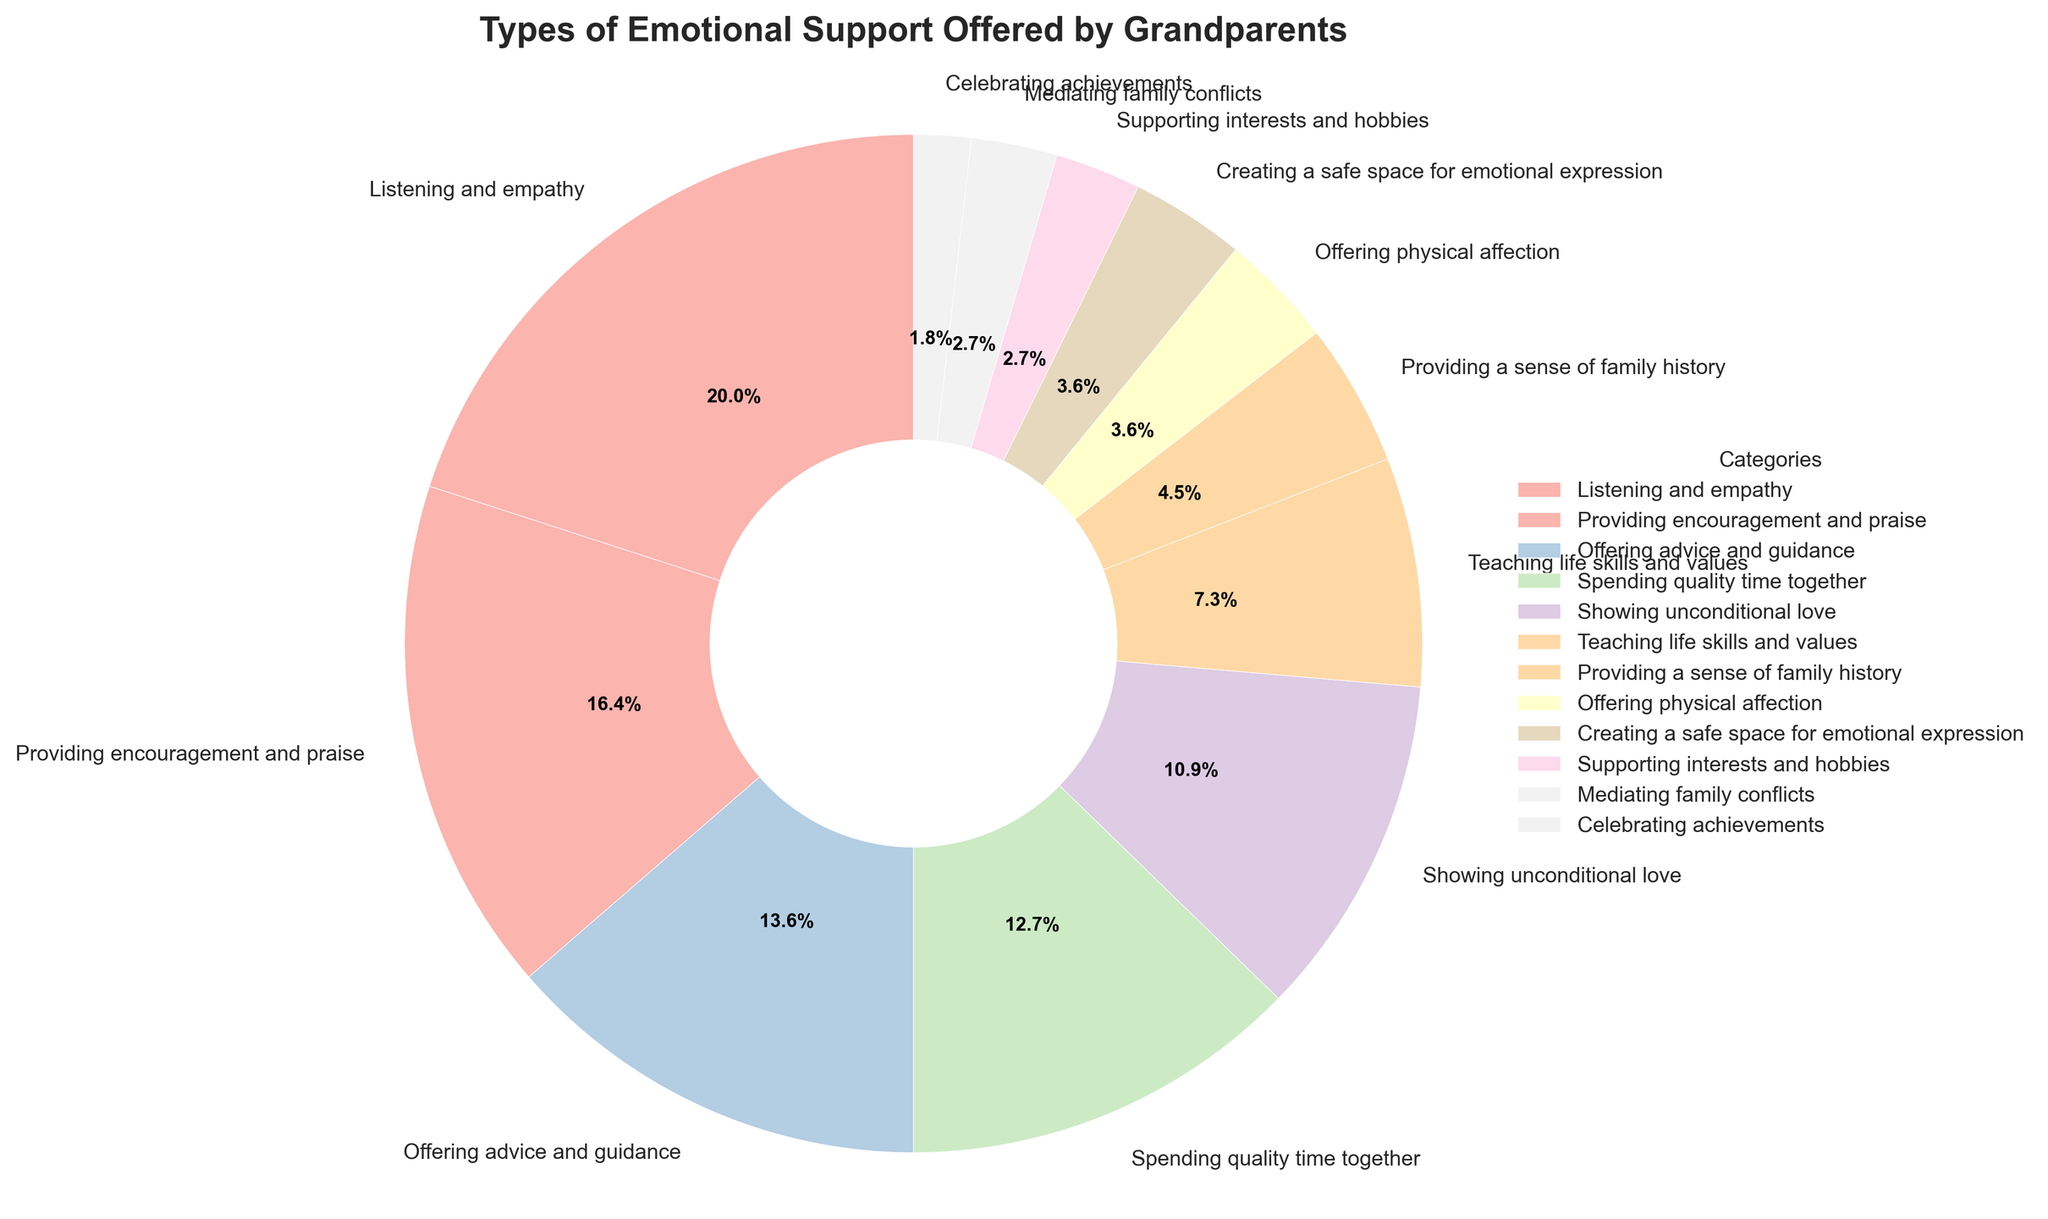What is the largest category of emotional support offered by grandparents? The largest slice of the pie chart represents the category with the highest percentage. Here, "Listening and empathy" has the largest slice, which is 22%.
Answer: Listening and empathy Which type of emotional support is more common: "Providing encouragement and praise" or "Offering advice and guidance"? To determine this, compare their percentages. "Providing encouragement and praise" is 18%, while "Offering advice and guidance" is 15%. Therefore, "Providing encouragement and praise" is more common.
Answer: Providing encouragement and praise How much more common is "Listening and empathy" compared to "Showing unconditional love"? Subtract the percentage of "Showing unconditional love" from the percentage of "Listening and empathy". So, 22% - 12% = 10%.
Answer: 10% What are the three least common types of emotional support offered by grandparents? The least common categories can be identified by the smallest slices in the pie chart. The three smallest slices are "Celebrating achievements" (2%), "Supporting interests and hobbies" (3%), and "Mediating family conflicts" (3%).
Answer: Celebrating achievements, Supporting interests and hobbies, Mediating family conflicts Which type of emotional support occupies the same percentage in the pie chart? "Offering physical affection" and "Creating a safe space for emotional expression" both have a percentage of 4% each.
Answer: Offering physical affection, Creating a safe space for emotional expression What percentage of emotional support is comprised of "Spending quality time together" and "Providing a sense of family history" combined? Add the percentages of the two categories. So, 14% (Spending quality time together) + 5% (Providing a sense of family history) = 19%.
Answer: 19% Which category has a percentage equal to the sum of "Providing a sense of family history" and "Celebrating achievements"? Find the sum of the two given percentages: 5% (Providing a sense of family history) + 2% (Celebrating achievements) = 7%. The category with this percentage is "Teaching life skills and values" at 8%.
Answer: None (closest is "Teaching life skills and values") How does the percentage of "Offering advice and guidance" compare to the percentage of "Spending quality time together"? Compare their percentages. "Offering advice and guidance" is 15%, while "Spending quality time together" is 14%. Hence, "Offering advice and guidance" is slightly higher.
Answer: Offering advice and guidance is slightly higher What is the total percentage of categories that account for less than 5% of emotional support? Add the percentages of the categories with less than 5% each: "Providing a sense of family history" (5%), "Offering physical affection" (4%), "Creating a safe space for emotional expression" (4%), "Supporting interests and hobbies" (3%), "Mediating family conflicts" (3%), and "Celebrating achievements" (2%). Therefore, 5% + 4% + 4% + 3% + 3% + 2% = 21%.
Answer: 21% What percentage of the pie chart combines "Spending quality time together," "Teaching life skills and values," and "Providing encouragement and praise"? Sum their percentages: 14% (Spending quality time together) + 8% (Teaching life skills and values) + 18% (Providing encouragement and praise) = 40%.
Answer: 40% 